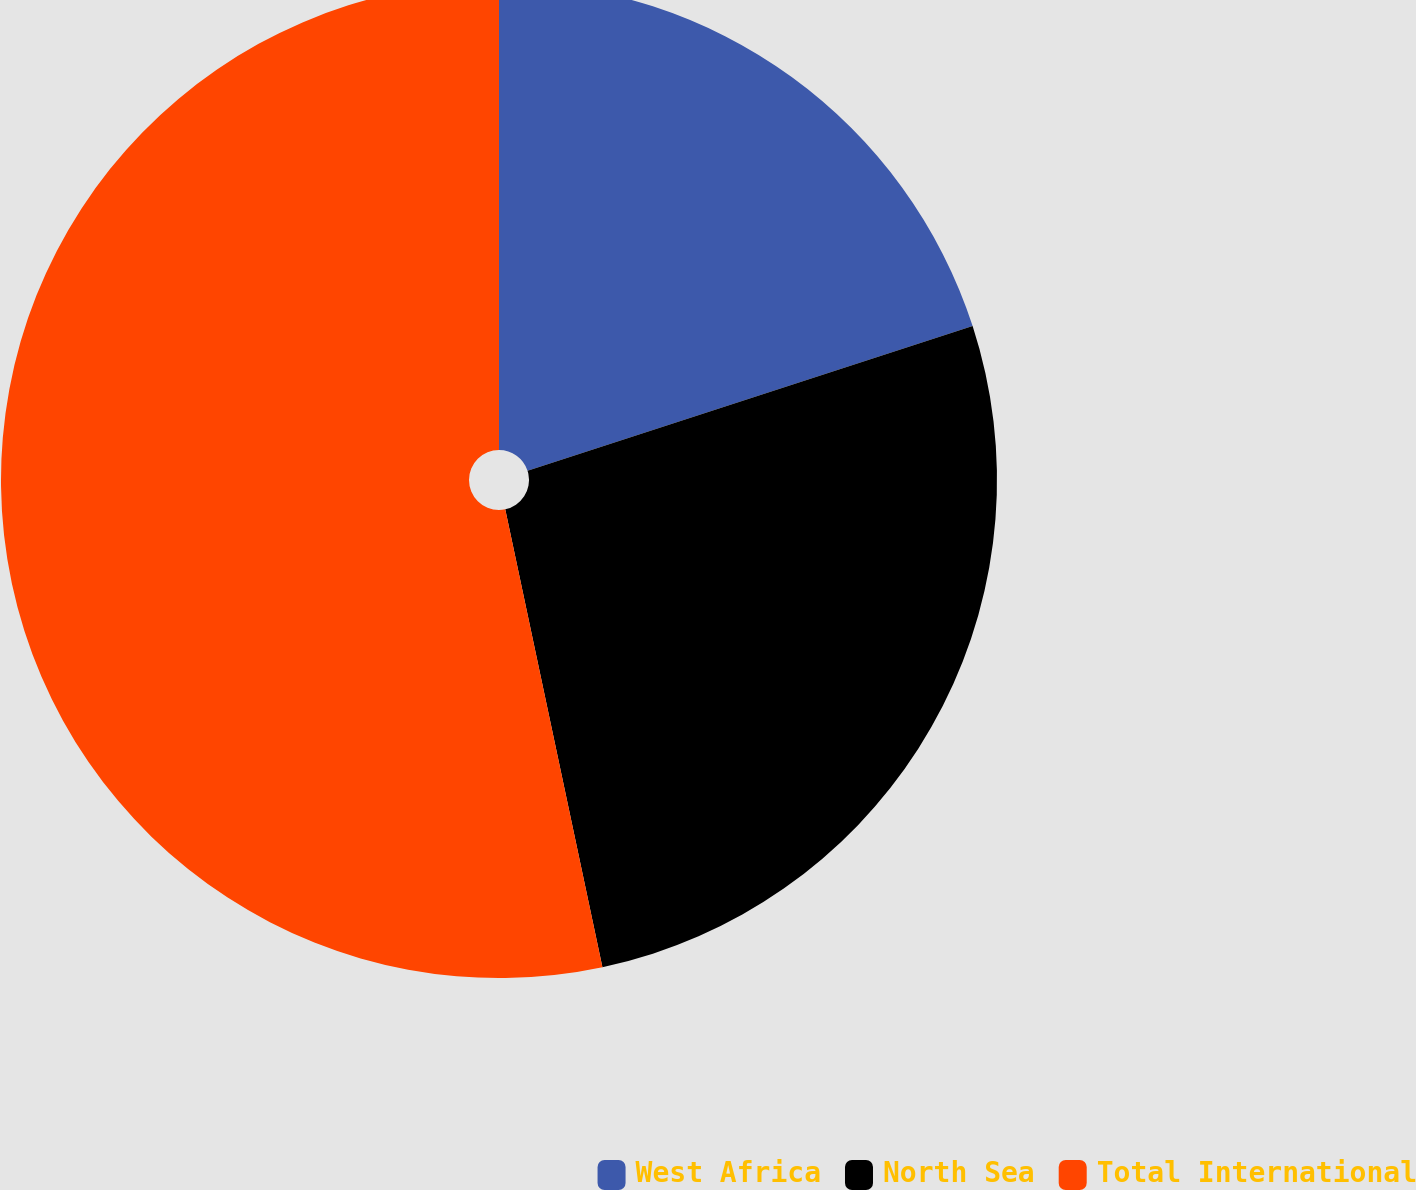<chart> <loc_0><loc_0><loc_500><loc_500><pie_chart><fcel>West Africa<fcel>North Sea<fcel>Total International<nl><fcel>20.0%<fcel>26.67%<fcel>53.33%<nl></chart> 